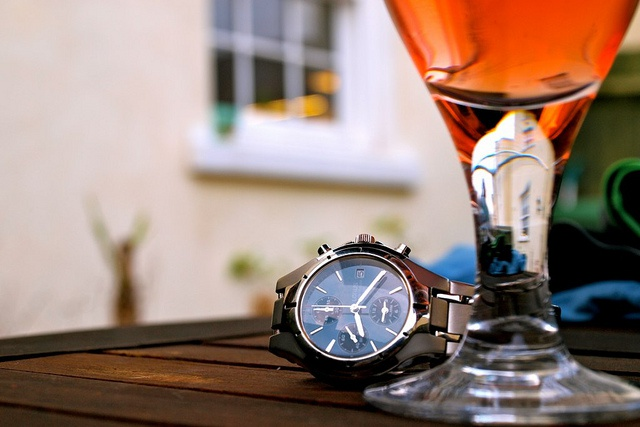Describe the objects in this image and their specific colors. I can see wine glass in lightgray, red, black, and gray tones, dining table in lightgray, maroon, black, and brown tones, and clock in lightgray, darkgray, black, and gray tones in this image. 